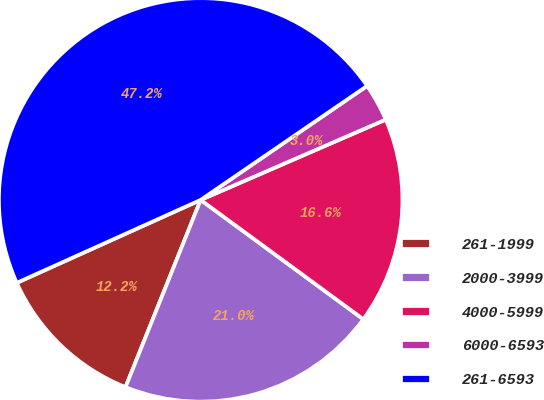<chart> <loc_0><loc_0><loc_500><loc_500><pie_chart><fcel>261-1999<fcel>2000-3999<fcel>4000-5999<fcel>6000-6593<fcel>261-6593<nl><fcel>12.18%<fcel>21.0%<fcel>16.59%<fcel>3.04%<fcel>47.18%<nl></chart> 